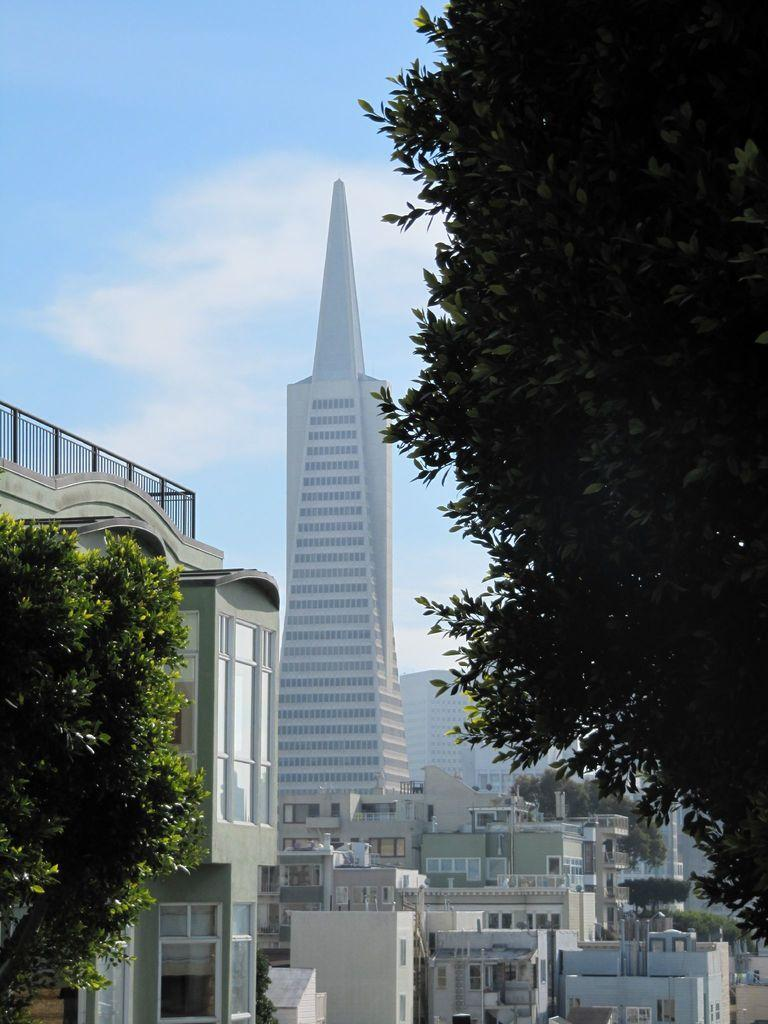What type of structures can be seen in the image? There are buildings in the image. What other natural elements are present in the image? There are trees in the image. What can be seen in the distance in the image? The sky is visible in the background of the image. How many pies are on the windowsill of the building in the image? There is no information about pies or a windowsill in the image, so it cannot be determined. 